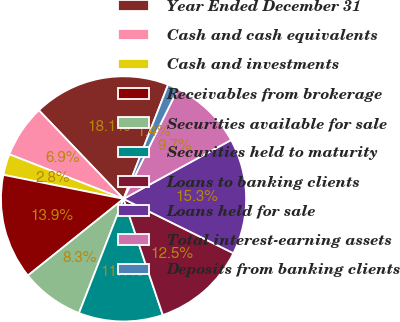<chart> <loc_0><loc_0><loc_500><loc_500><pie_chart><fcel>Year Ended December 31<fcel>Cash and cash equivalents<fcel>Cash and investments<fcel>Receivables from brokerage<fcel>Securities available for sale<fcel>Securities held to maturity<fcel>Loans to banking clients<fcel>Loans held for sale<fcel>Total interest-earning assets<fcel>Deposits from banking clients<nl><fcel>18.06%<fcel>6.94%<fcel>2.78%<fcel>13.89%<fcel>8.33%<fcel>11.11%<fcel>12.5%<fcel>15.28%<fcel>9.72%<fcel>1.39%<nl></chart> 